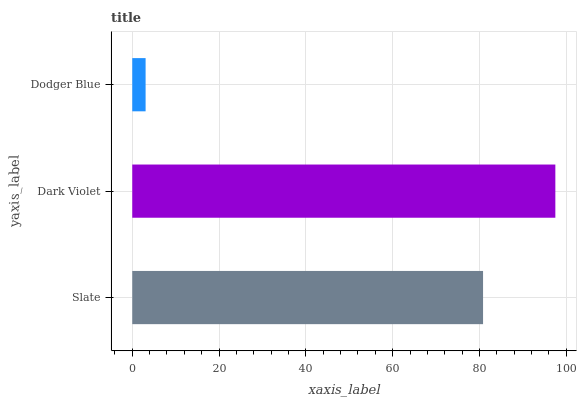Is Dodger Blue the minimum?
Answer yes or no. Yes. Is Dark Violet the maximum?
Answer yes or no. Yes. Is Dark Violet the minimum?
Answer yes or no. No. Is Dodger Blue the maximum?
Answer yes or no. No. Is Dark Violet greater than Dodger Blue?
Answer yes or no. Yes. Is Dodger Blue less than Dark Violet?
Answer yes or no. Yes. Is Dodger Blue greater than Dark Violet?
Answer yes or no. No. Is Dark Violet less than Dodger Blue?
Answer yes or no. No. Is Slate the high median?
Answer yes or no. Yes. Is Slate the low median?
Answer yes or no. Yes. Is Dark Violet the high median?
Answer yes or no. No. Is Dark Violet the low median?
Answer yes or no. No. 